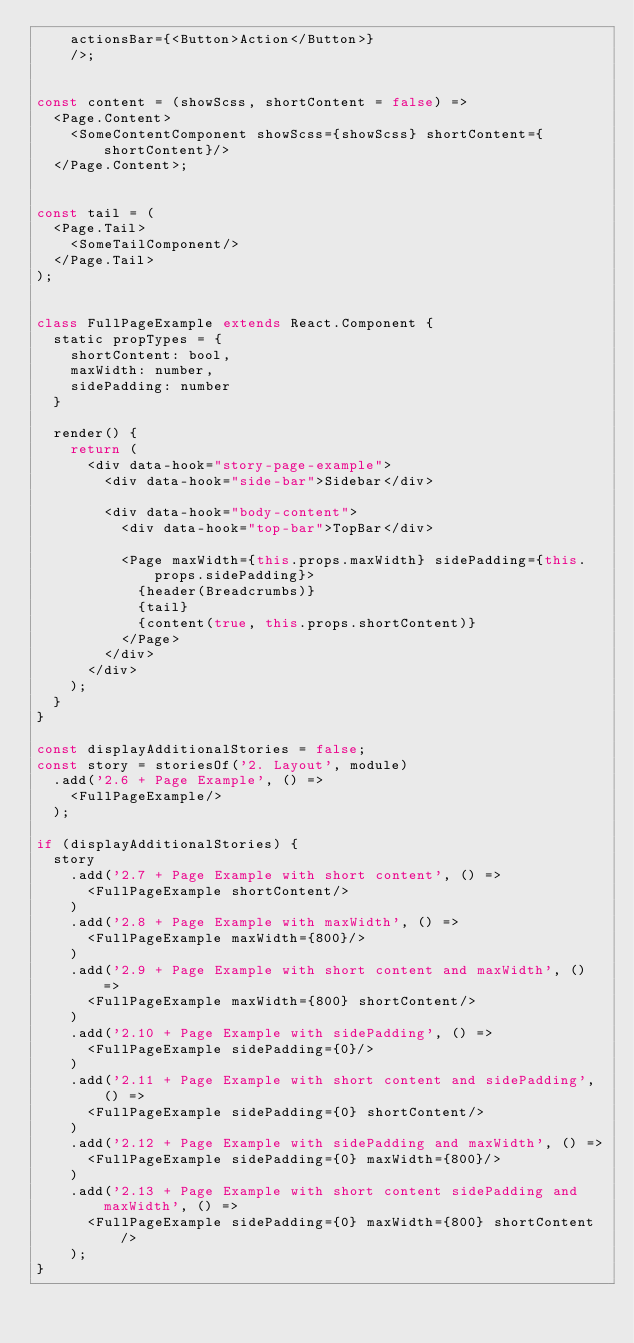Convert code to text. <code><loc_0><loc_0><loc_500><loc_500><_JavaScript_>    actionsBar={<Button>Action</Button>}
    />;


const content = (showScss, shortContent = false) =>
  <Page.Content>
    <SomeContentComponent showScss={showScss} shortContent={shortContent}/>
  </Page.Content>;


const tail = (
  <Page.Tail>
    <SomeTailComponent/>
  </Page.Tail>
);


class FullPageExample extends React.Component {
  static propTypes = {
    shortContent: bool,
    maxWidth: number,
    sidePadding: number
  }

  render() {
    return (
      <div data-hook="story-page-example">
        <div data-hook="side-bar">Sidebar</div>

        <div data-hook="body-content">
          <div data-hook="top-bar">TopBar</div>

          <Page maxWidth={this.props.maxWidth} sidePadding={this.props.sidePadding}>
            {header(Breadcrumbs)}
            {tail}
            {content(true, this.props.shortContent)}
          </Page>
        </div>
      </div>
    );
  }
}

const displayAdditionalStories = false;
const story = storiesOf('2. Layout', module)
  .add('2.6 + Page Example', () =>
    <FullPageExample/>
  );

if (displayAdditionalStories) {
  story
    .add('2.7 + Page Example with short content', () =>
      <FullPageExample shortContent/>
    )
    .add('2.8 + Page Example with maxWidth', () =>
      <FullPageExample maxWidth={800}/>
    )
    .add('2.9 + Page Example with short content and maxWidth', () =>
      <FullPageExample maxWidth={800} shortContent/>
    )
    .add('2.10 + Page Example with sidePadding', () =>
      <FullPageExample sidePadding={0}/>
    )
    .add('2.11 + Page Example with short content and sidePadding', () =>
      <FullPageExample sidePadding={0} shortContent/>
    )
    .add('2.12 + Page Example with sidePadding and maxWidth', () =>
      <FullPageExample sidePadding={0} maxWidth={800}/>
    )
    .add('2.13 + Page Example with short content sidePadding and maxWidth', () =>
      <FullPageExample sidePadding={0} maxWidth={800} shortContent/>
    );
}
</code> 